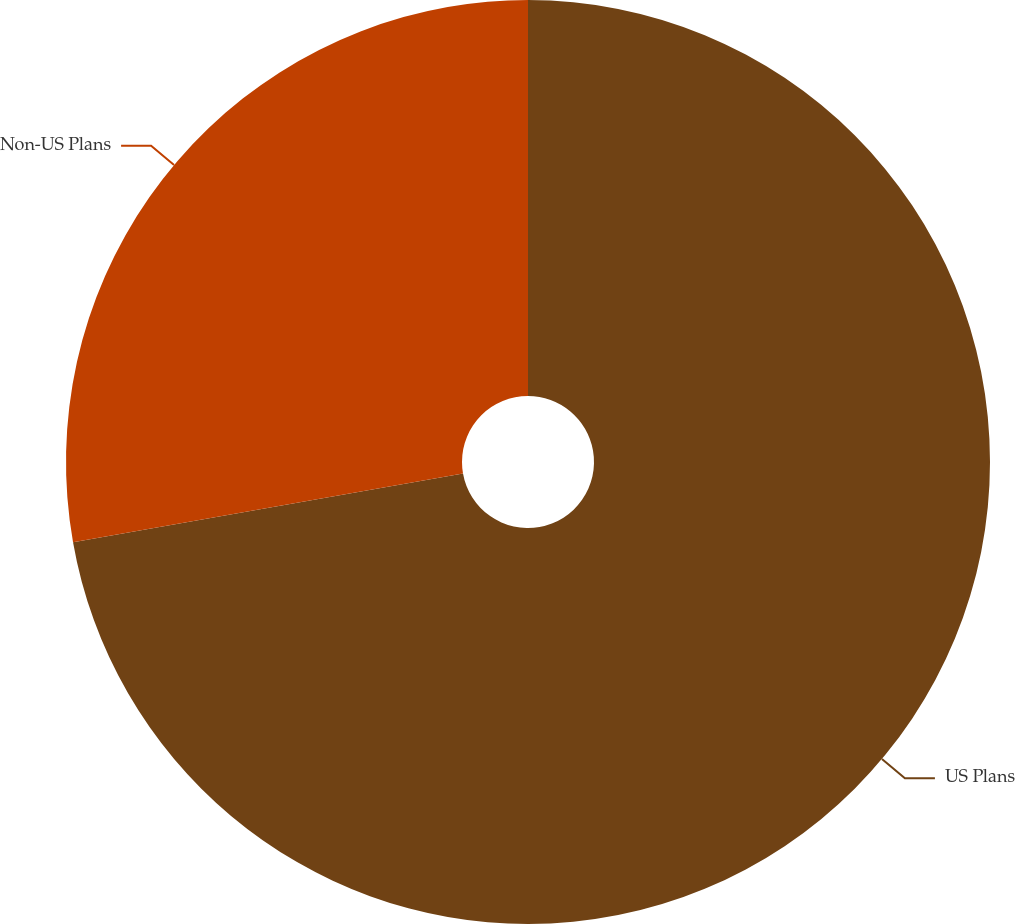Convert chart to OTSL. <chart><loc_0><loc_0><loc_500><loc_500><pie_chart><fcel>US Plans<fcel>Non-US Plans<nl><fcel>72.22%<fcel>27.78%<nl></chart> 